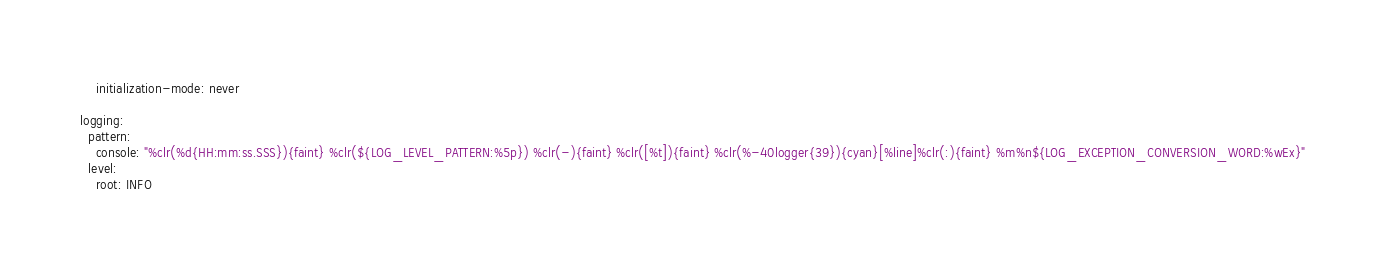Convert code to text. <code><loc_0><loc_0><loc_500><loc_500><_YAML_>    initialization-mode: never

logging:
  pattern:
    console: "%clr(%d{HH:mm:ss.SSS}){faint} %clr(${LOG_LEVEL_PATTERN:%5p}) %clr(-){faint} %clr([%t]){faint} %clr(%-40logger{39}){cyan}[%line]%clr(:){faint} %m%n${LOG_EXCEPTION_CONVERSION_WORD:%wEx}"
  level:
    root: INFO
</code> 